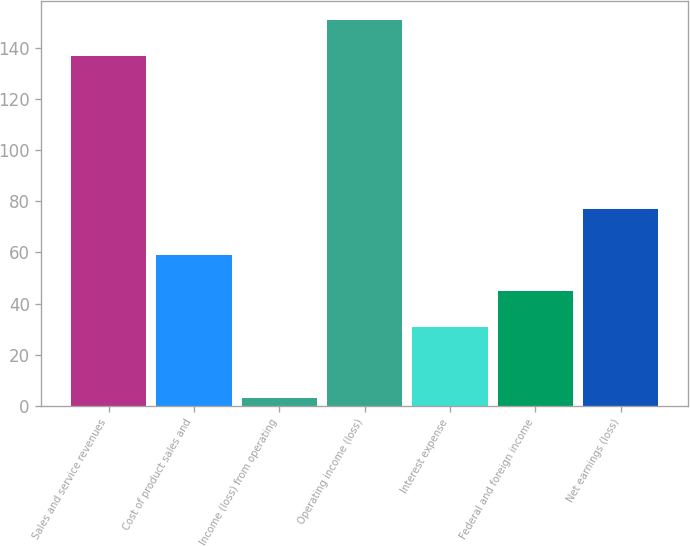<chart> <loc_0><loc_0><loc_500><loc_500><bar_chart><fcel>Sales and service revenues<fcel>Cost of product sales and<fcel>Income (loss) from operating<fcel>Operating income (loss)<fcel>Interest expense<fcel>Federal and foreign income<fcel>Net earnings (loss)<nl><fcel>137<fcel>59<fcel>3<fcel>151<fcel>31<fcel>45<fcel>77<nl></chart> 